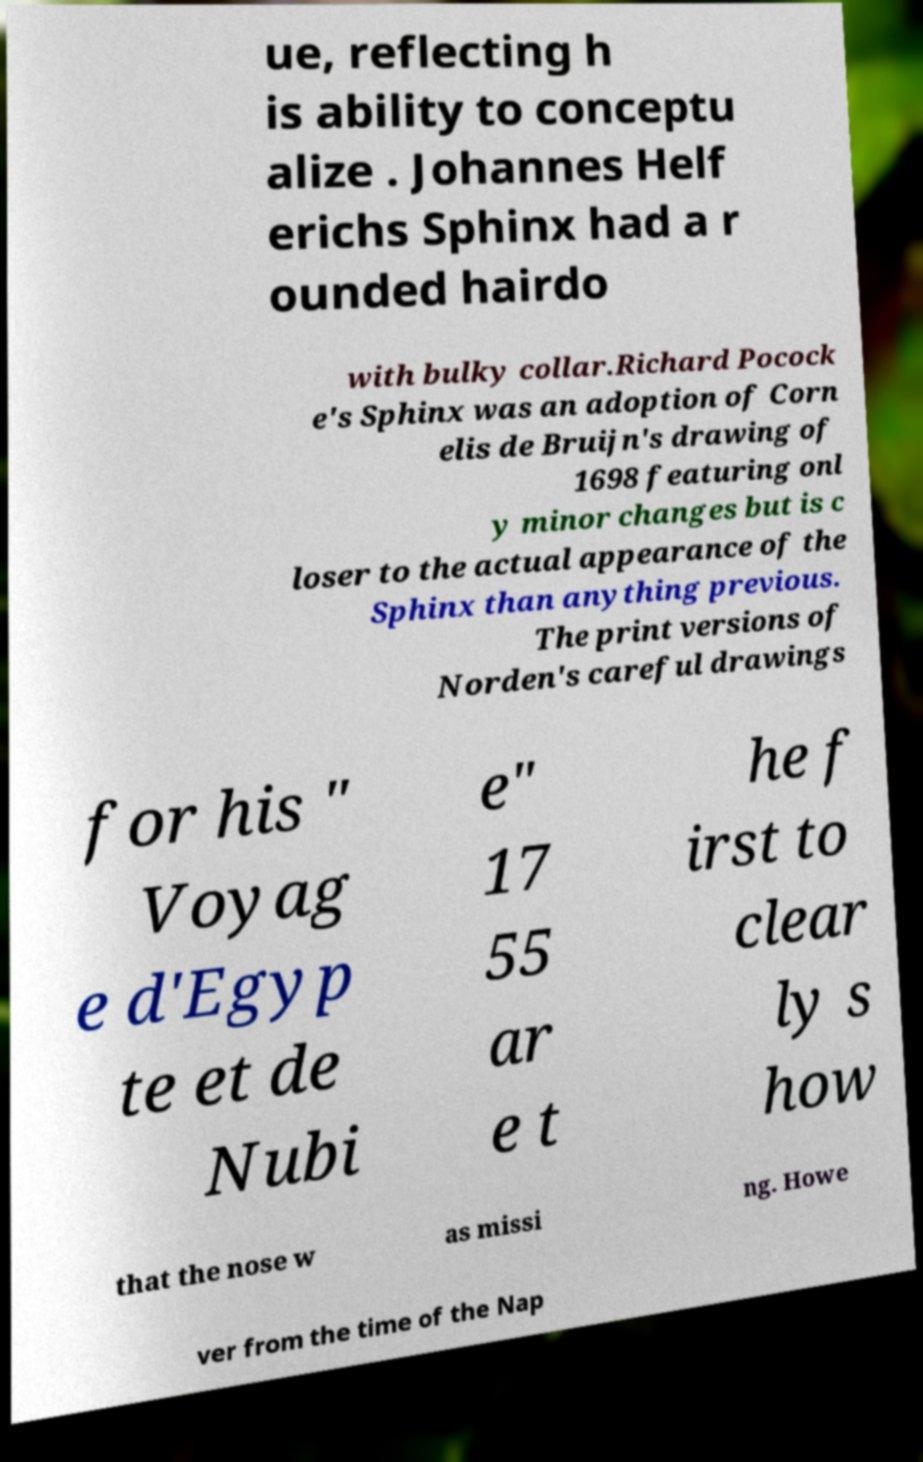There's text embedded in this image that I need extracted. Can you transcribe it verbatim? ue, reflecting h is ability to conceptu alize . Johannes Helf erichs Sphinx had a r ounded hairdo with bulky collar.Richard Pocock e's Sphinx was an adoption of Corn elis de Bruijn's drawing of 1698 featuring onl y minor changes but is c loser to the actual appearance of the Sphinx than anything previous. The print versions of Norden's careful drawings for his " Voyag e d'Egyp te et de Nubi e" 17 55 ar e t he f irst to clear ly s how that the nose w as missi ng. Howe ver from the time of the Nap 